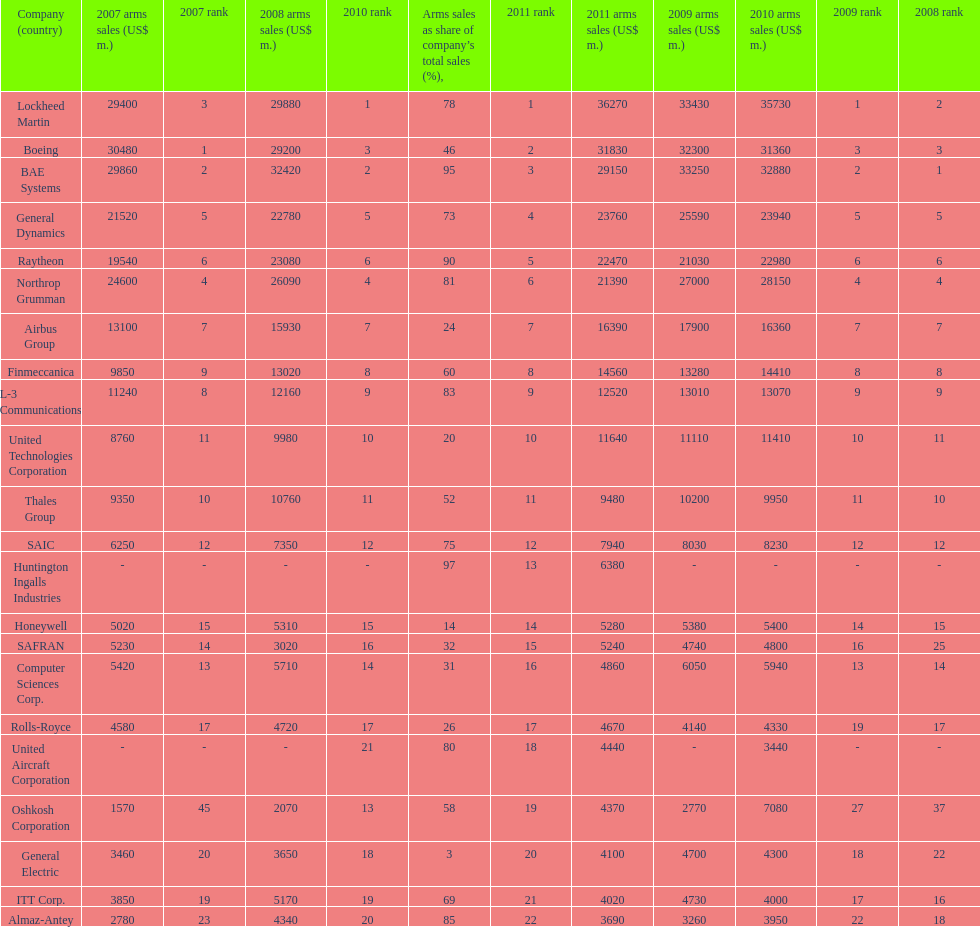Which is the only company to have under 10% arms sales as share of company's total sales? General Electric. 